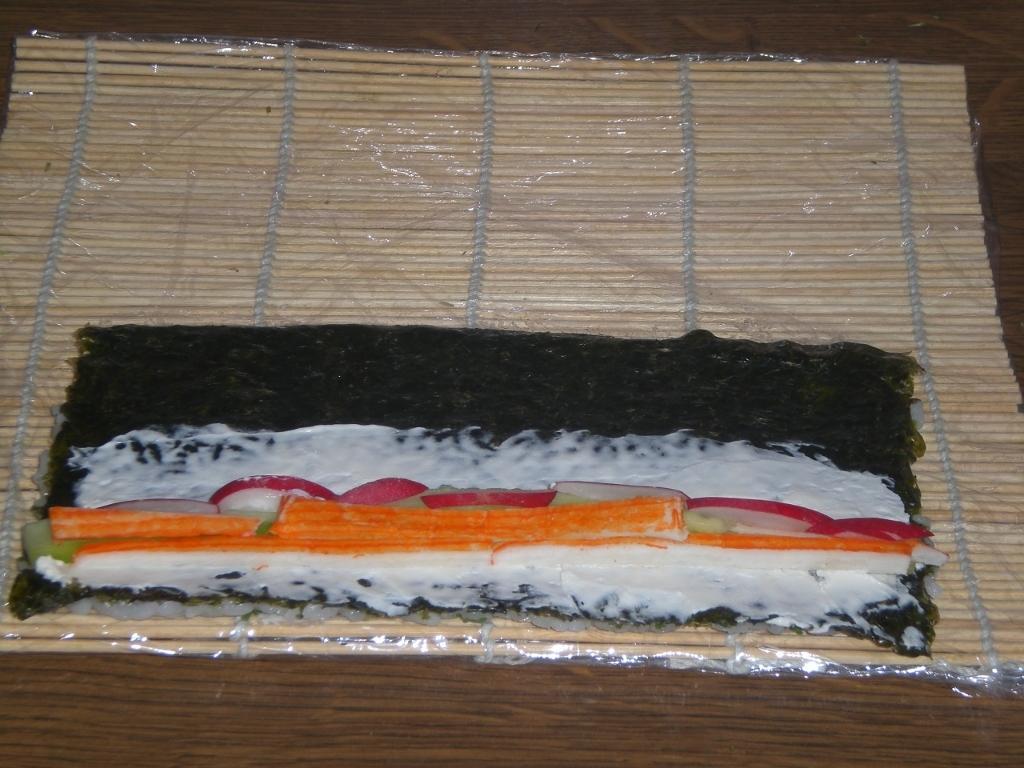In one or two sentences, can you explain what this image depicts? In this image I can see the food on the bamboo-sticks. It is on the brown color surface. 